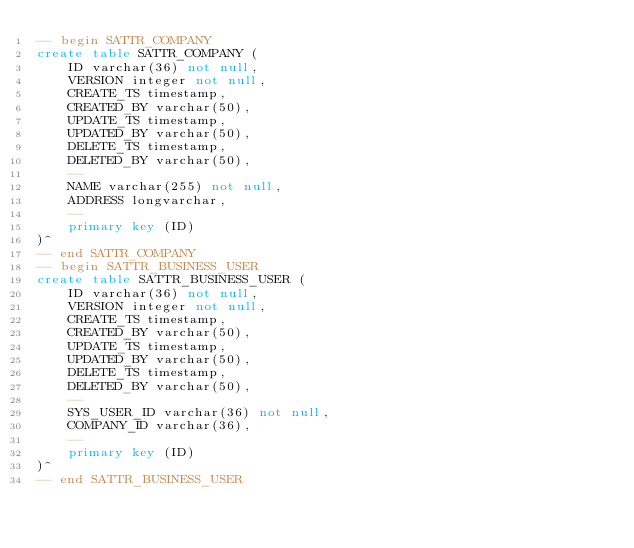<code> <loc_0><loc_0><loc_500><loc_500><_SQL_>-- begin SATTR_COMPANY
create table SATTR_COMPANY (
    ID varchar(36) not null,
    VERSION integer not null,
    CREATE_TS timestamp,
    CREATED_BY varchar(50),
    UPDATE_TS timestamp,
    UPDATED_BY varchar(50),
    DELETE_TS timestamp,
    DELETED_BY varchar(50),
    --
    NAME varchar(255) not null,
    ADDRESS longvarchar,
    --
    primary key (ID)
)^
-- end SATTR_COMPANY
-- begin SATTR_BUSINESS_USER
create table SATTR_BUSINESS_USER (
    ID varchar(36) not null,
    VERSION integer not null,
    CREATE_TS timestamp,
    CREATED_BY varchar(50),
    UPDATE_TS timestamp,
    UPDATED_BY varchar(50),
    DELETE_TS timestamp,
    DELETED_BY varchar(50),
    --
    SYS_USER_ID varchar(36) not null,
    COMPANY_ID varchar(36),
    --
    primary key (ID)
)^
-- end SATTR_BUSINESS_USER
</code> 